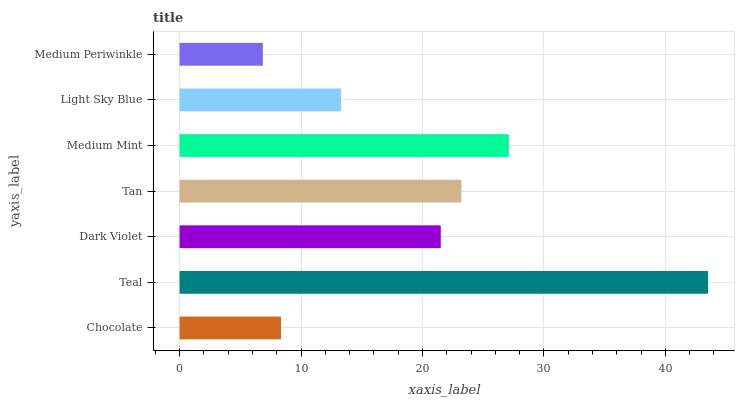Is Medium Periwinkle the minimum?
Answer yes or no. Yes. Is Teal the maximum?
Answer yes or no. Yes. Is Dark Violet the minimum?
Answer yes or no. No. Is Dark Violet the maximum?
Answer yes or no. No. Is Teal greater than Dark Violet?
Answer yes or no. Yes. Is Dark Violet less than Teal?
Answer yes or no. Yes. Is Dark Violet greater than Teal?
Answer yes or no. No. Is Teal less than Dark Violet?
Answer yes or no. No. Is Dark Violet the high median?
Answer yes or no. Yes. Is Dark Violet the low median?
Answer yes or no. Yes. Is Tan the high median?
Answer yes or no. No. Is Light Sky Blue the low median?
Answer yes or no. No. 